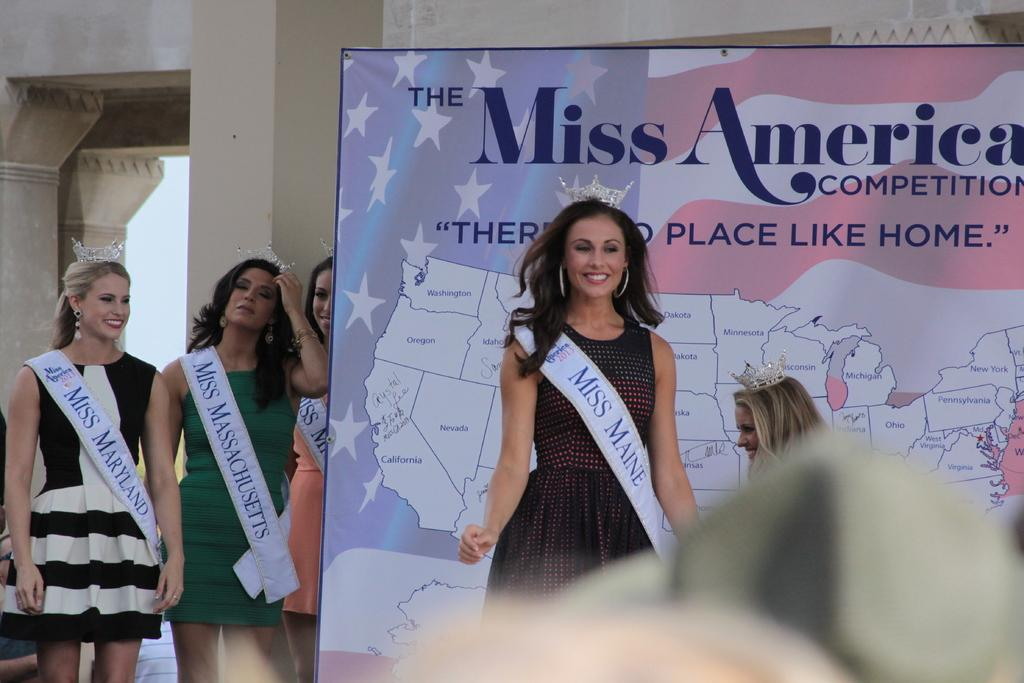<image>
Offer a succinct explanation of the picture presented. a miss america ad with people next to it 